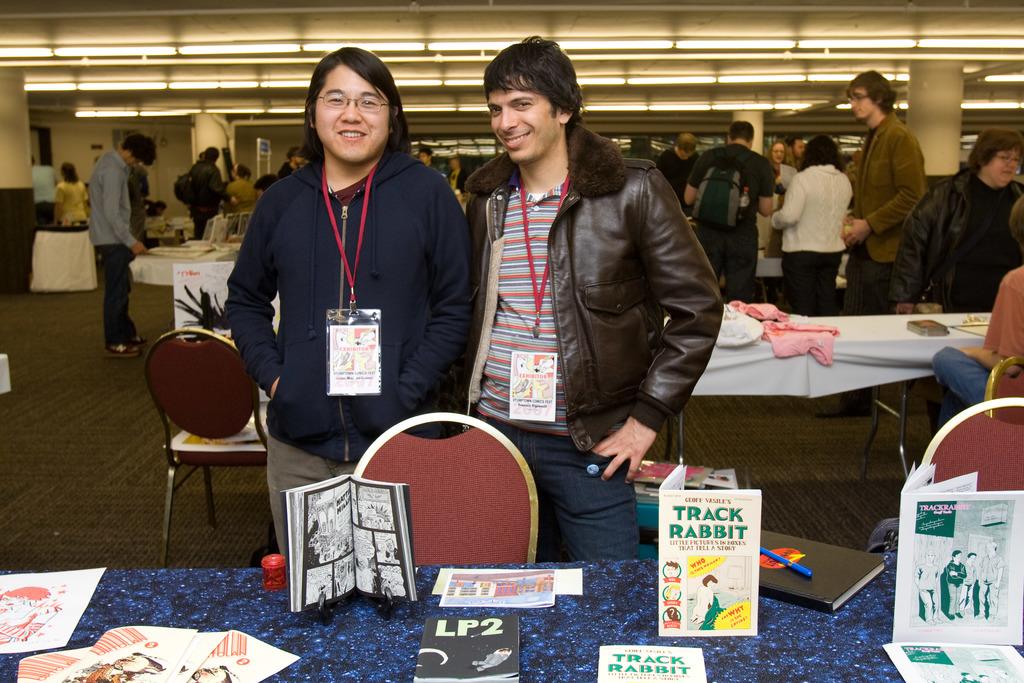What is the title of the book?
Offer a very short reply. Track rabbit. 